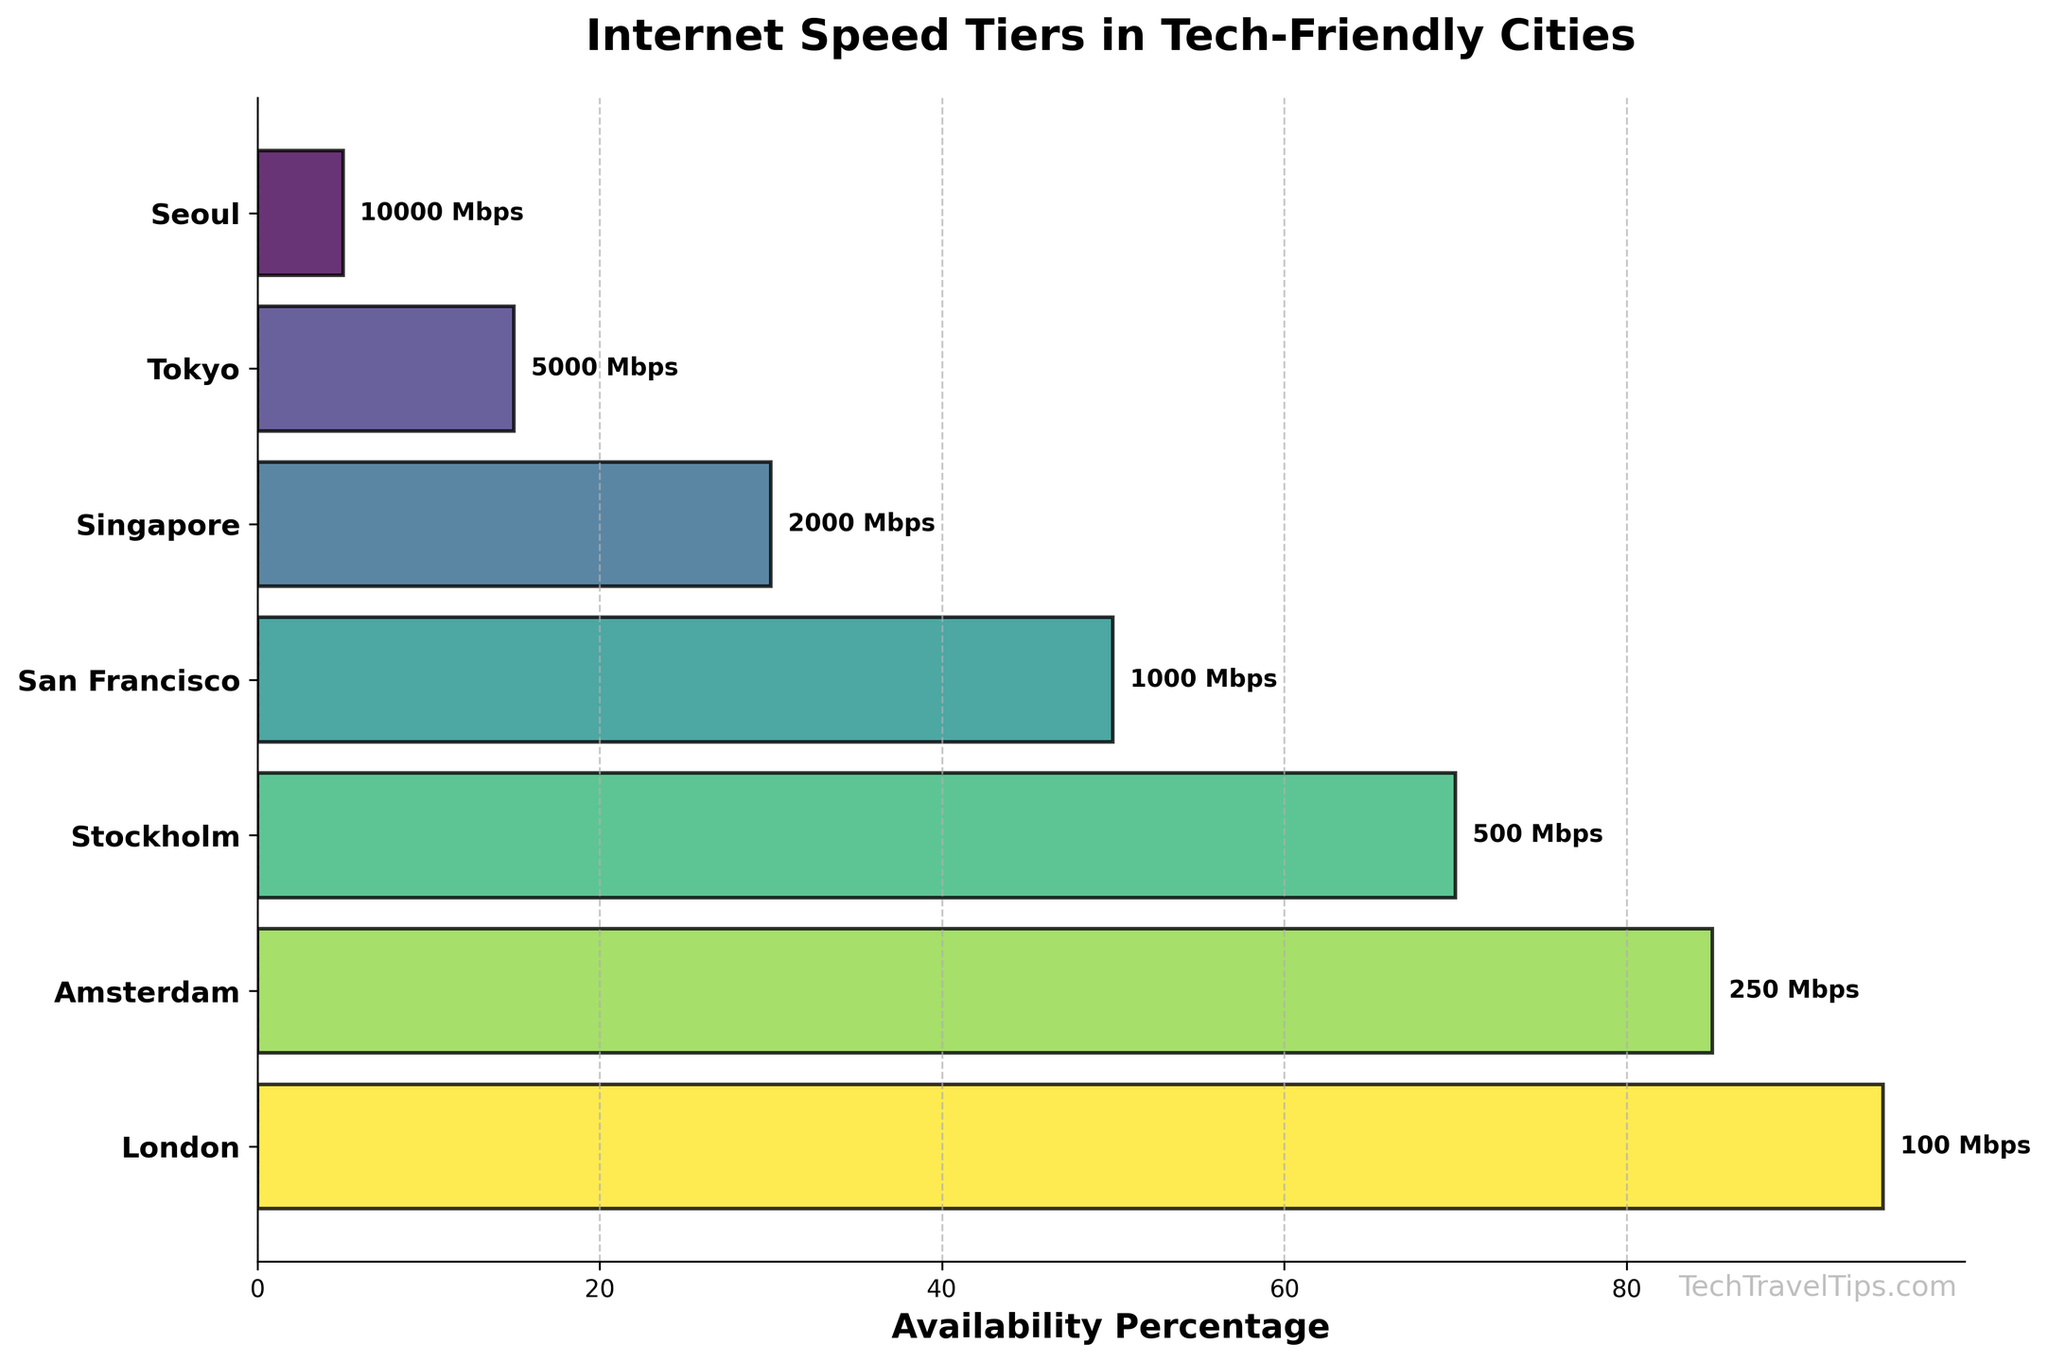What's the title of the figure? The title is always displayed at the top of the chart. It helps users understand what the chart represents. In this case, it's provided in the code which results in the title of the figure.
Answer: Internet Speed Tiers in Tech-Friendly Cities How many cities are displayed in the chart? Count the number of cities listed on the y-axis. Each city corresponds to a bar in the chart.
Answer: 7 Which city has the highest internet speed tier? Look for the city label at the very top of the inverted y-axis since the chart is designed to show the fastest tier at the top.
Answer: Seoul Which city has the lowest internet speed tier? Find the city label at the very bottom of the inverted y-axis, which represents the slowest tier.
Answer: London What is the internet speed tier of Tokyo? Find Tokyo on the y-axis and look next to the bar corresponding to it. The speed tier is labeled directly on the bar.
Answer: 5000 Mbps Which city has the highest availability percentage? Compare the lengths of the bars since the bar length represents the availability percentage. The longest bar corresponds to the highest percentage.
Answer: London What is the difference in availability percentage between San Francisco and Stockholm? Identify the percentages for both cities by examining the lengths of their bars. Then subtract the smaller percentage from the larger one: 70% - 50% = 20%
Answer: 20% Between Singapore and Amsterdam, which city has a higher internet speed tier? Compare the speed tiers labeled directly on the bars for both cities. The city with the higher tier will be the answer.
Answer: Singapore How do the availabilities of Seoul's and Tokyo's internet speed tiers compare? Look at the bars for Seoul and Tokyo. Compare the length of both bars to determine which one has a higher availability.
Answer: Tokyo has higher availability than Seoul What's the average availability percentage for all the cities? Sum all the availability percentages and divide by the number of cities: (5% + 15% + 30% + 50% + 70% + 85% + 95%) / 7 = 50%
Answer: 50% 